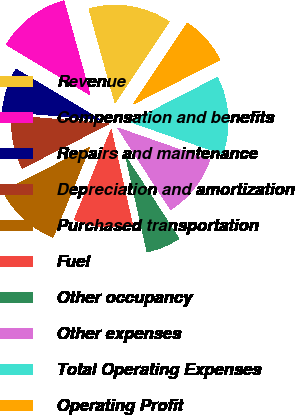<chart> <loc_0><loc_0><loc_500><loc_500><pie_chart><fcel>Revenue<fcel>Compensation and benefits<fcel>Repairs and maintenance<fcel>Depreciation and amortization<fcel>Purchased transportation<fcel>Fuel<fcel>Other occupancy<fcel>Other expenses<fcel>Total Operating Expenses<fcel>Operating Profit<nl><fcel>13.71%<fcel>12.1%<fcel>7.26%<fcel>8.87%<fcel>11.29%<fcel>9.68%<fcel>5.65%<fcel>10.48%<fcel>12.9%<fcel>8.06%<nl></chart> 